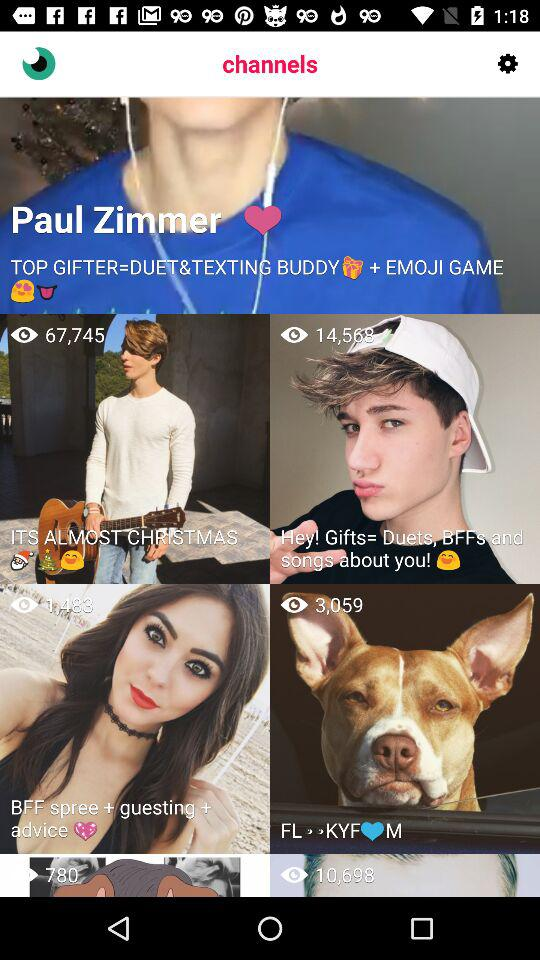How many views are there on "BFF spree"? There are 1,483 views on "BFF spree". 